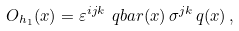<formula> <loc_0><loc_0><loc_500><loc_500>O _ { h _ { 1 } } ( x ) = \varepsilon ^ { i j k } \ q b a r ( x ) \, \sigma ^ { j k } \, q ( x ) \, ,</formula> 